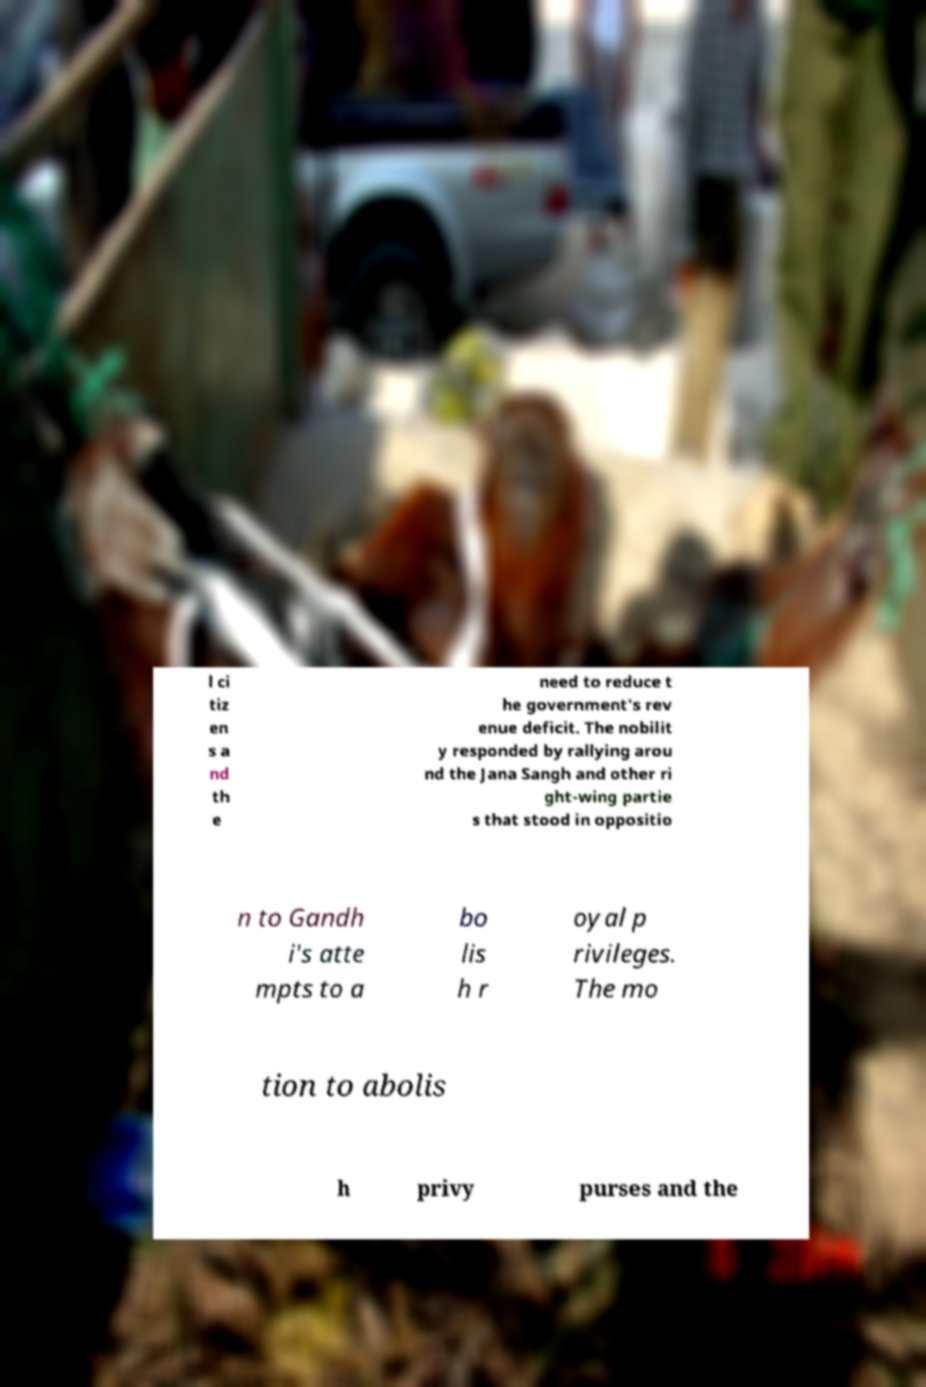Could you assist in decoding the text presented in this image and type it out clearly? l ci tiz en s a nd th e need to reduce t he government's rev enue deficit. The nobilit y responded by rallying arou nd the Jana Sangh and other ri ght-wing partie s that stood in oppositio n to Gandh i's atte mpts to a bo lis h r oyal p rivileges. The mo tion to abolis h privy purses and the 